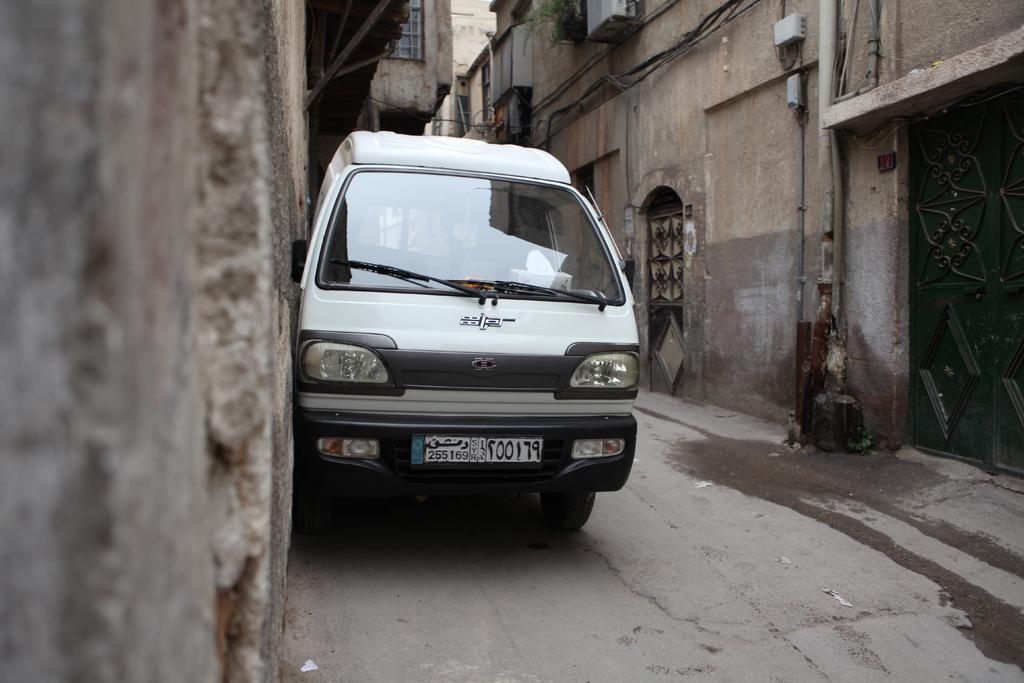What type of structures can be seen in the image? There are buildings in the image. What feature is common among the buildings? There are windows in the image. What mode of transportation is present in the image? There is a white color truck in the image. What type of debt is being discussed in the image? There is no mention of debt in the image; it features buildings, windows, and a white color truck. How many shades of green can be seen on the truck in the image? The image does not specify the color of the truck as green, and even if it were, we cannot determine the number of shades from the image. 